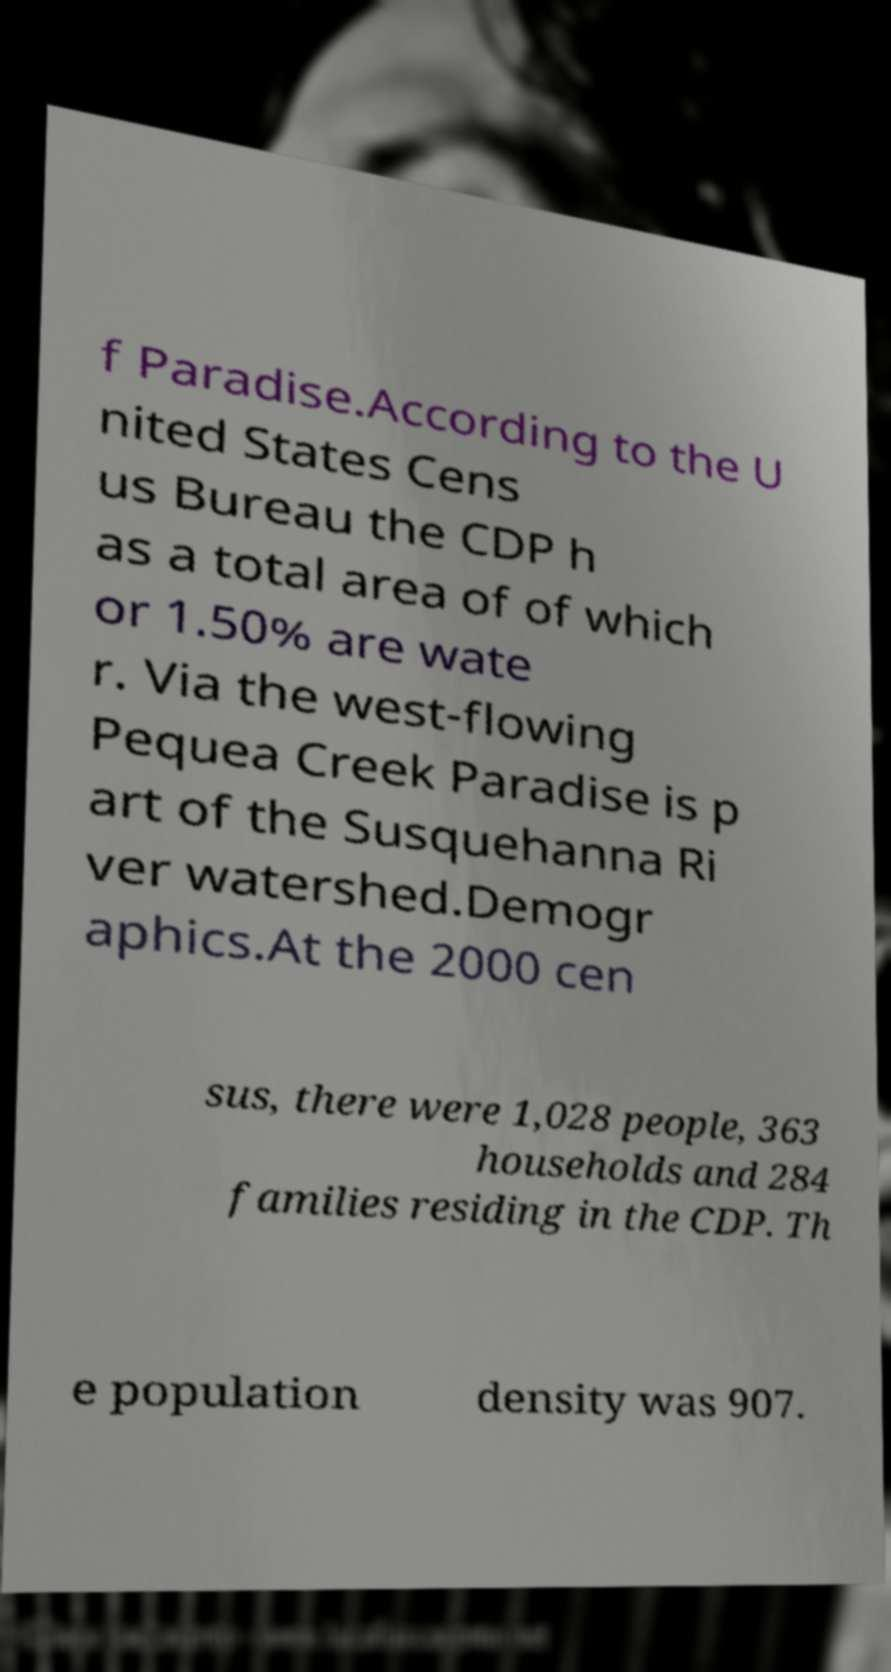There's text embedded in this image that I need extracted. Can you transcribe it verbatim? f Paradise.According to the U nited States Cens us Bureau the CDP h as a total area of of which or 1.50% are wate r. Via the west-flowing Pequea Creek Paradise is p art of the Susquehanna Ri ver watershed.Demogr aphics.At the 2000 cen sus, there were 1,028 people, 363 households and 284 families residing in the CDP. Th e population density was 907. 